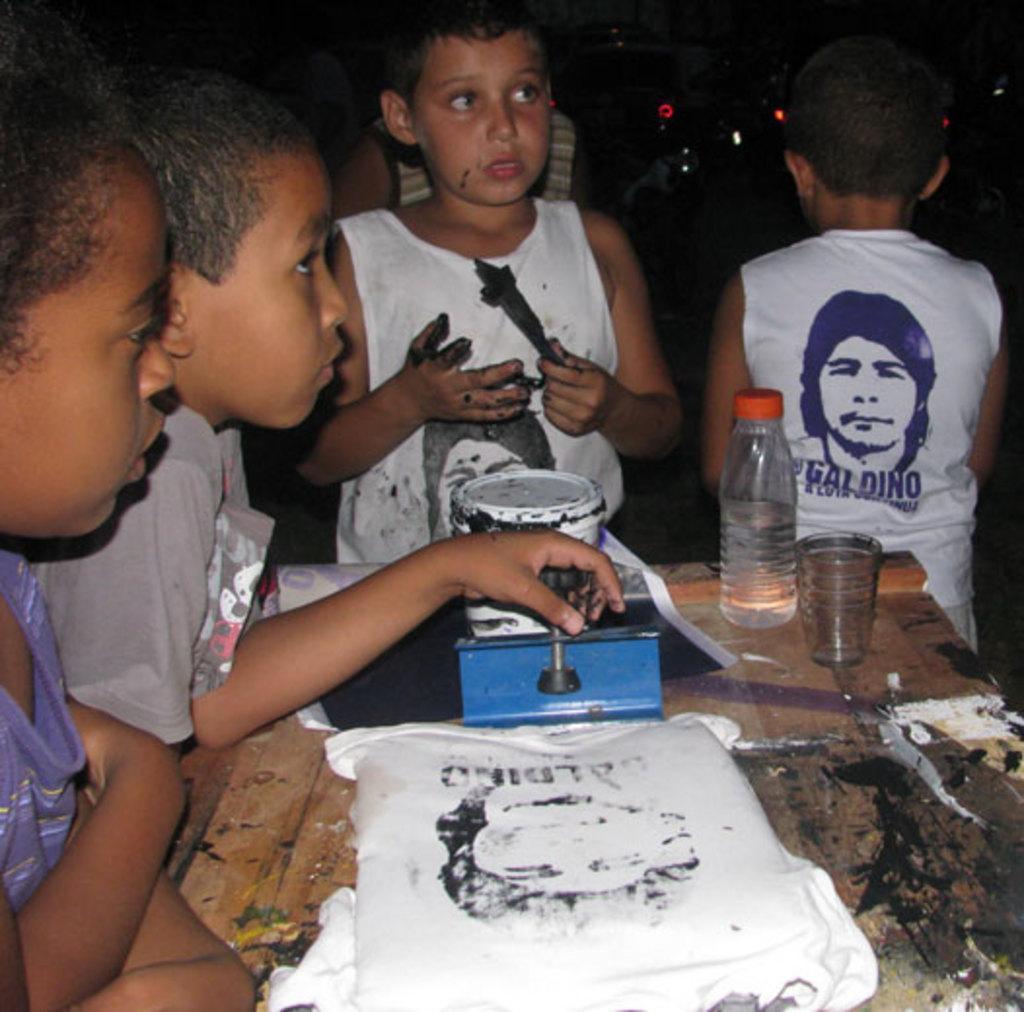Describe this image in one or two sentences. In this image we can see the kids. We can also see a glass, bottle and some other objects on the table. We can see a painting box. In the background we can see the lights. 